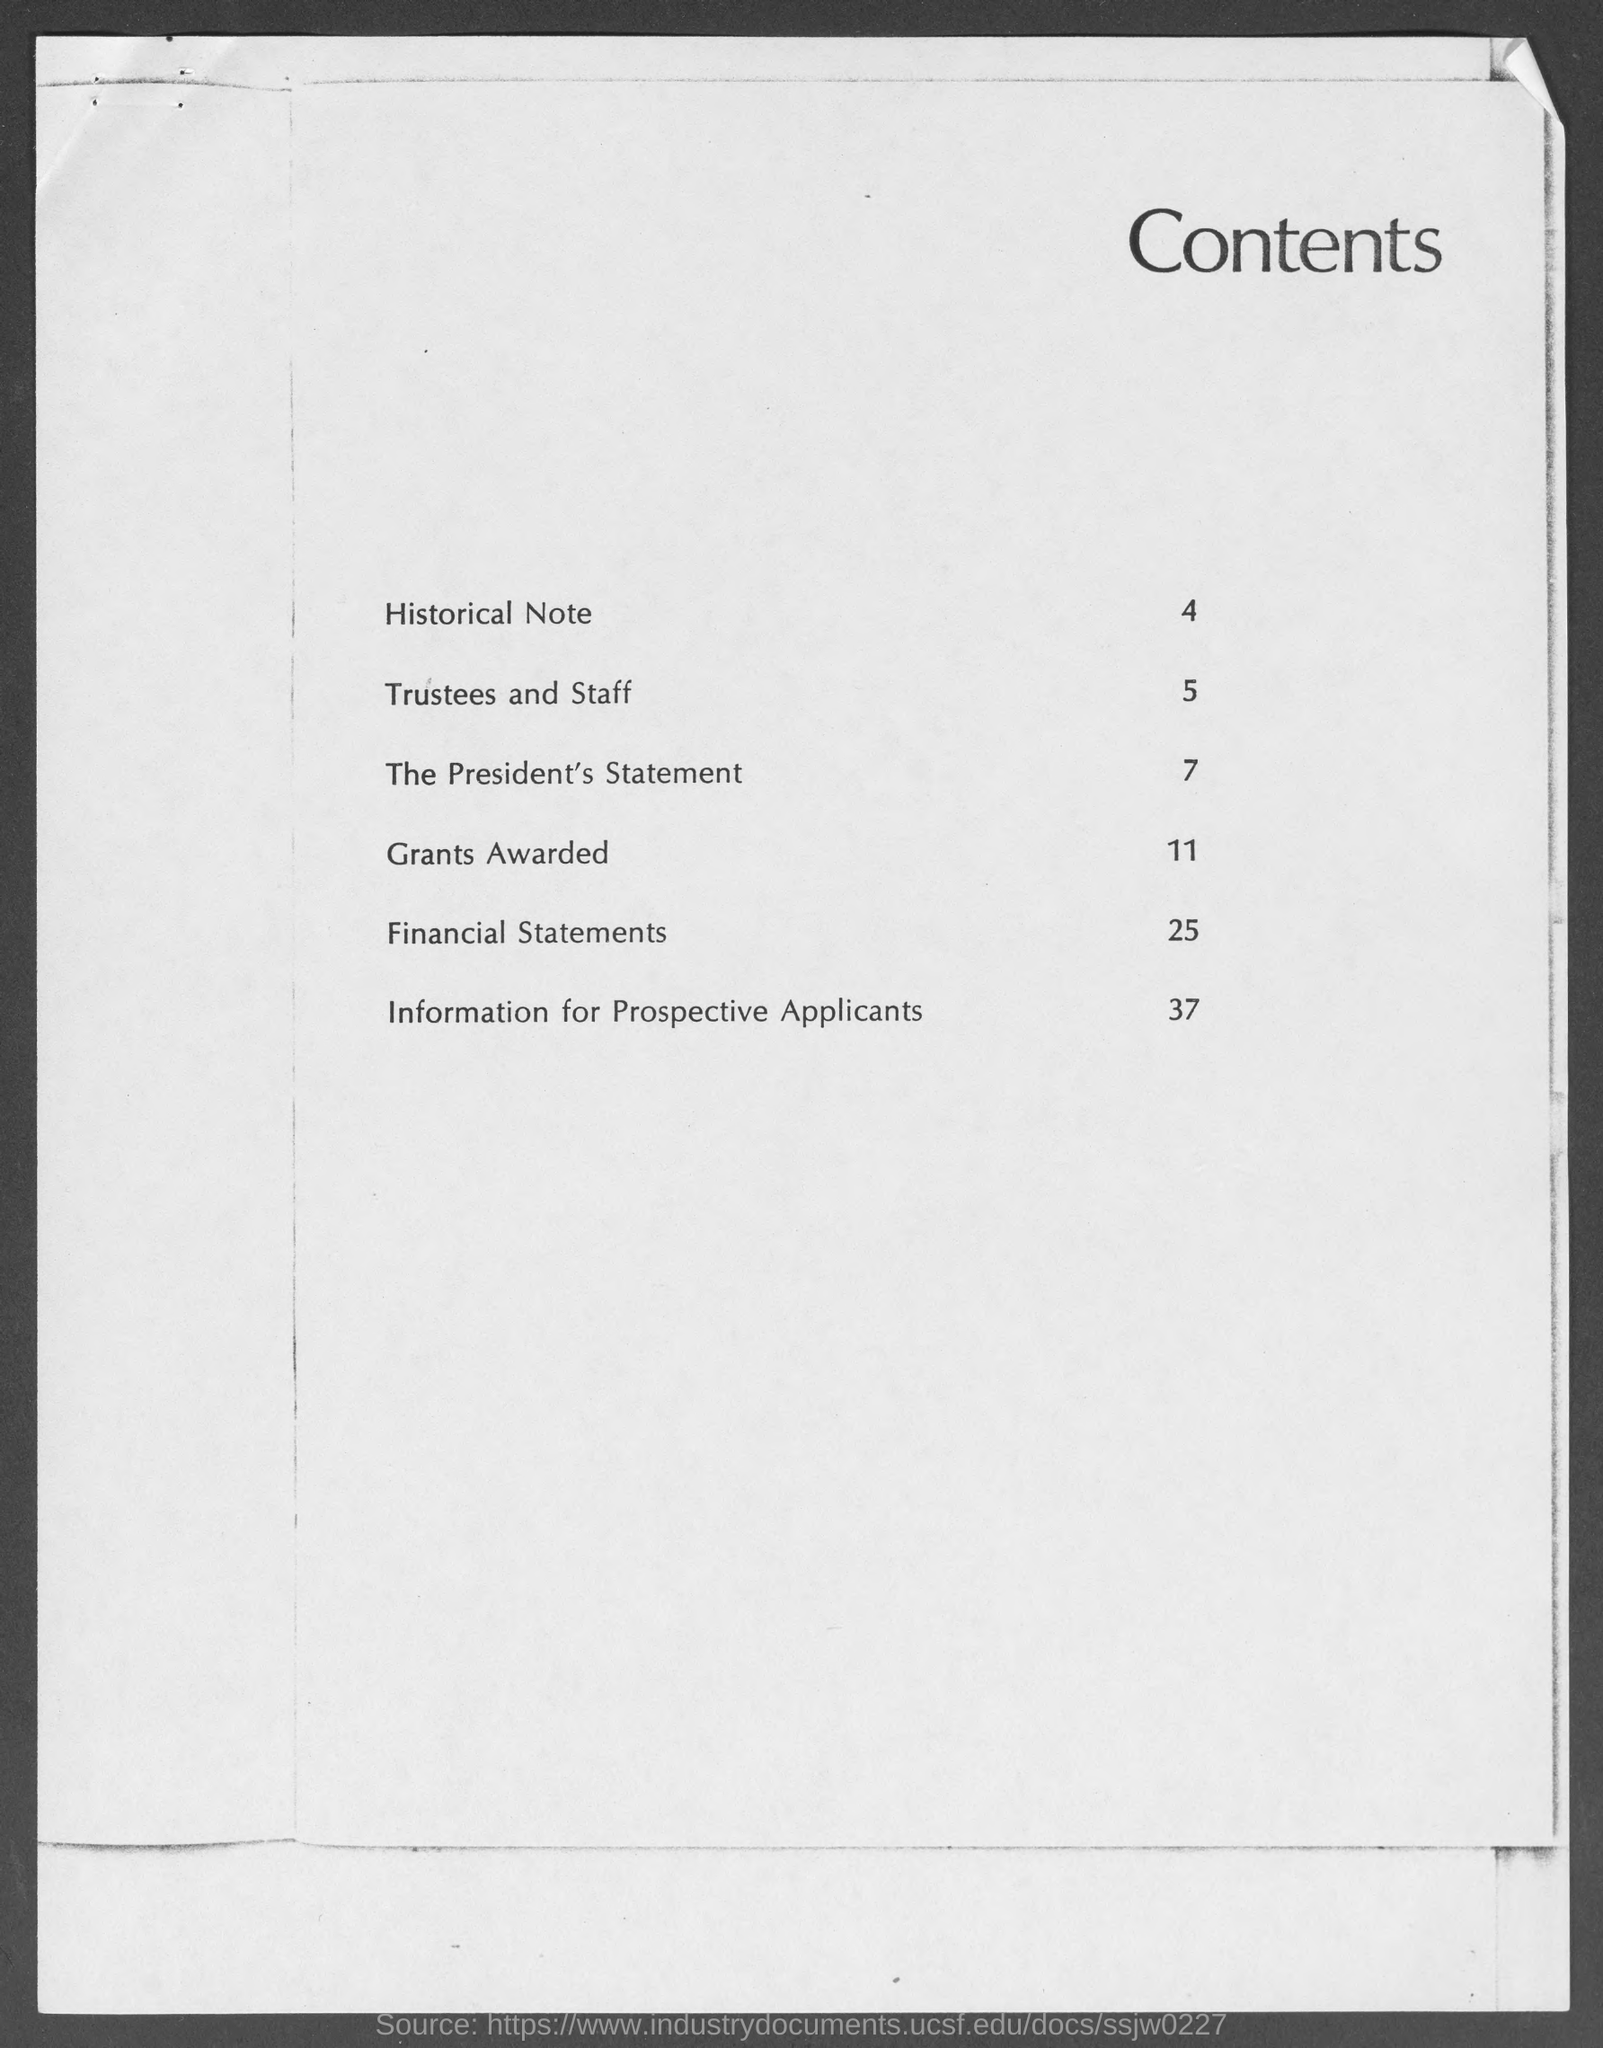Outline some significant characteristics in this image. The heading at the top of the page is "Contents. 